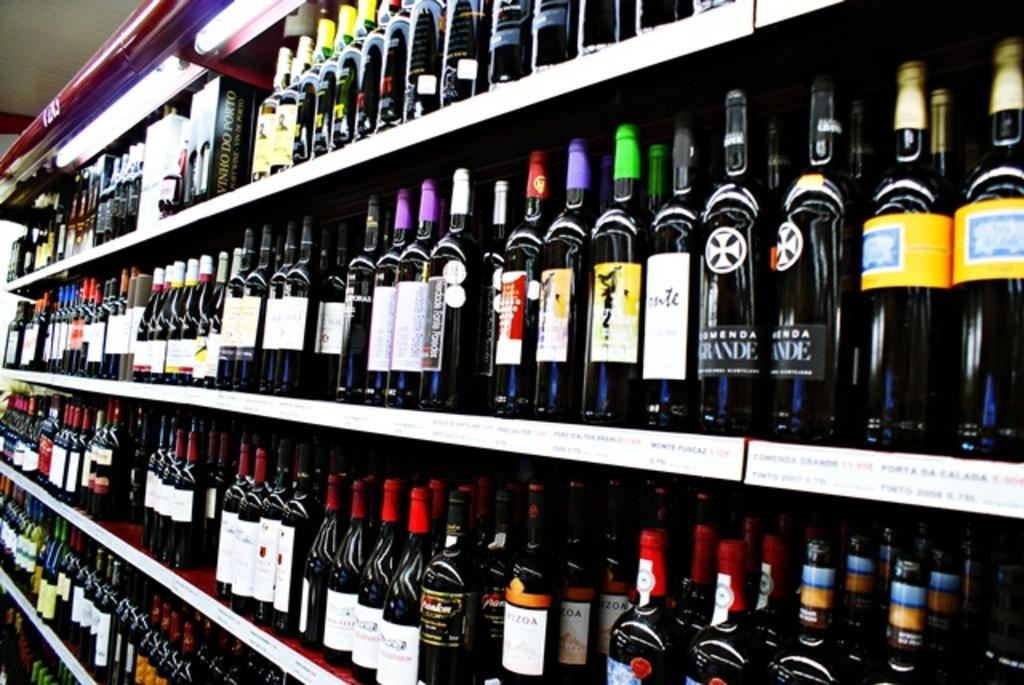<image>
Summarize the visual content of the image. Many shelves of liquor include one brand labeled with Grande. 